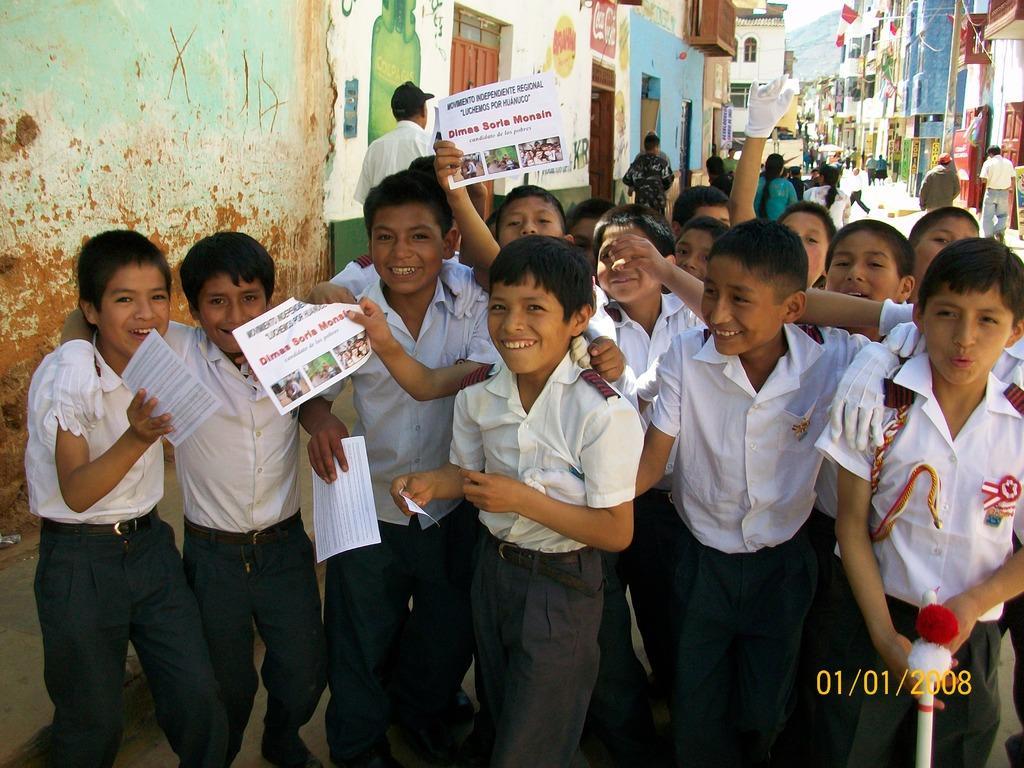How would you summarize this image in a sentence or two? In this image we can see a group of children holding the papers. On the backside we can see a person walking, some buildings with windows and the sky. 